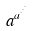Convert formula to latex. <formula><loc_0><loc_0><loc_500><loc_500>a ^ { a ^ { \cdot ^ { \cdot ^ { \cdot } } } }</formula> 